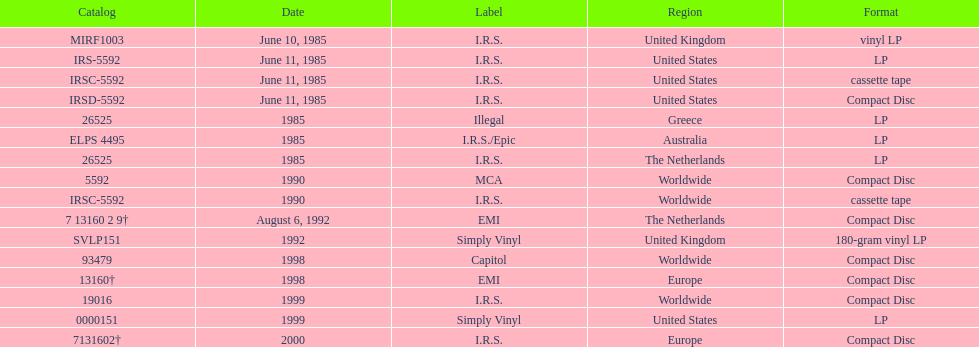In how many countries was the album released before 1990? 5. 